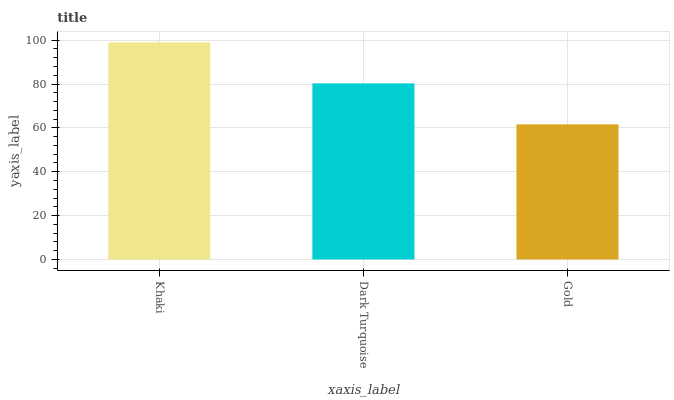Is Dark Turquoise the minimum?
Answer yes or no. No. Is Dark Turquoise the maximum?
Answer yes or no. No. Is Khaki greater than Dark Turquoise?
Answer yes or no. Yes. Is Dark Turquoise less than Khaki?
Answer yes or no. Yes. Is Dark Turquoise greater than Khaki?
Answer yes or no. No. Is Khaki less than Dark Turquoise?
Answer yes or no. No. Is Dark Turquoise the high median?
Answer yes or no. Yes. Is Dark Turquoise the low median?
Answer yes or no. Yes. Is Gold the high median?
Answer yes or no. No. Is Khaki the low median?
Answer yes or no. No. 